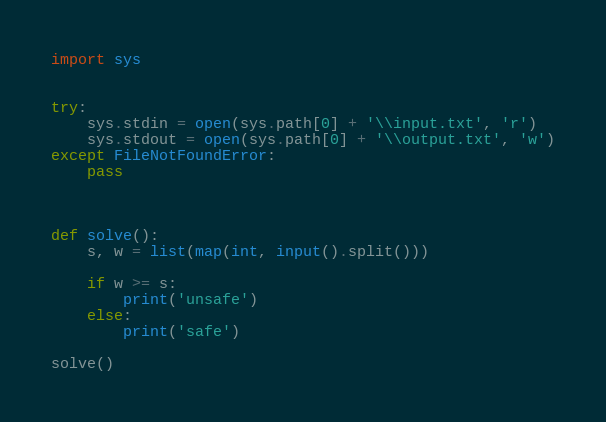Convert code to text. <code><loc_0><loc_0><loc_500><loc_500><_Python_>import sys


try:
    sys.stdin = open(sys.path[0] + '\\input.txt', 'r')
    sys.stdout = open(sys.path[0] + '\\output.txt', 'w')
except FileNotFoundError:
    pass



def solve():
    s, w = list(map(int, input().split()))

    if w >= s:
        print('unsafe')
    else:
        print('safe')

solve()
</code> 